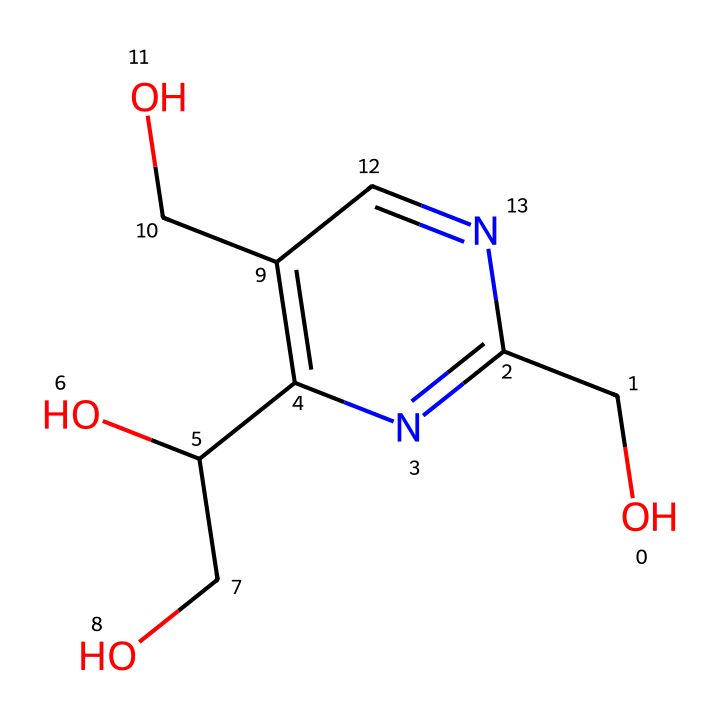what is the primary functional group present in this structure? The primary functional group can be identified by looking for characteristic groups in the chemical structure. This structure features a hydroxyl group (-OH) attached to the carbon chain, indicating the presence of alcohol functional groups.
Answer: hydroxyl group how many carbon atoms are present in the chemical? To identify the number of carbon atoms, count all the carbon atoms in the structure visually. There are six carbon atoms connected in the structure.
Answer: six how does vitamin B6 participate in neurotransmitter synthesis? Vitamin B6, represented in this chemical structure, is involved in the synthesis of neurotransmitters such as serotonin and dopamine. This is facilitated through the action of its active form, pyridoxal phosphate, which acts as a coenzyme in various enzymatic reactions.
Answer: through enzymatic reactions what is the total number of nitrogen atoms in this compound? Count the nitrogen atoms in the structure. There is one nitrogen atom present in this chemical, which is crucial for its biological function.
Answer: one what specific vitamin does this SMILES notation represent? By recognizing the structural features closely associated with the given SMILES notation, we can identify it as vitamin B6, which is involved in numerous biological processes.
Answer: vitamin B6 does this compound contain any double bonds? A visual inspection of the chemical structure shows that there is at least one double bond connecting the nitrogen with adjacent carbon atoms.
Answer: yes 